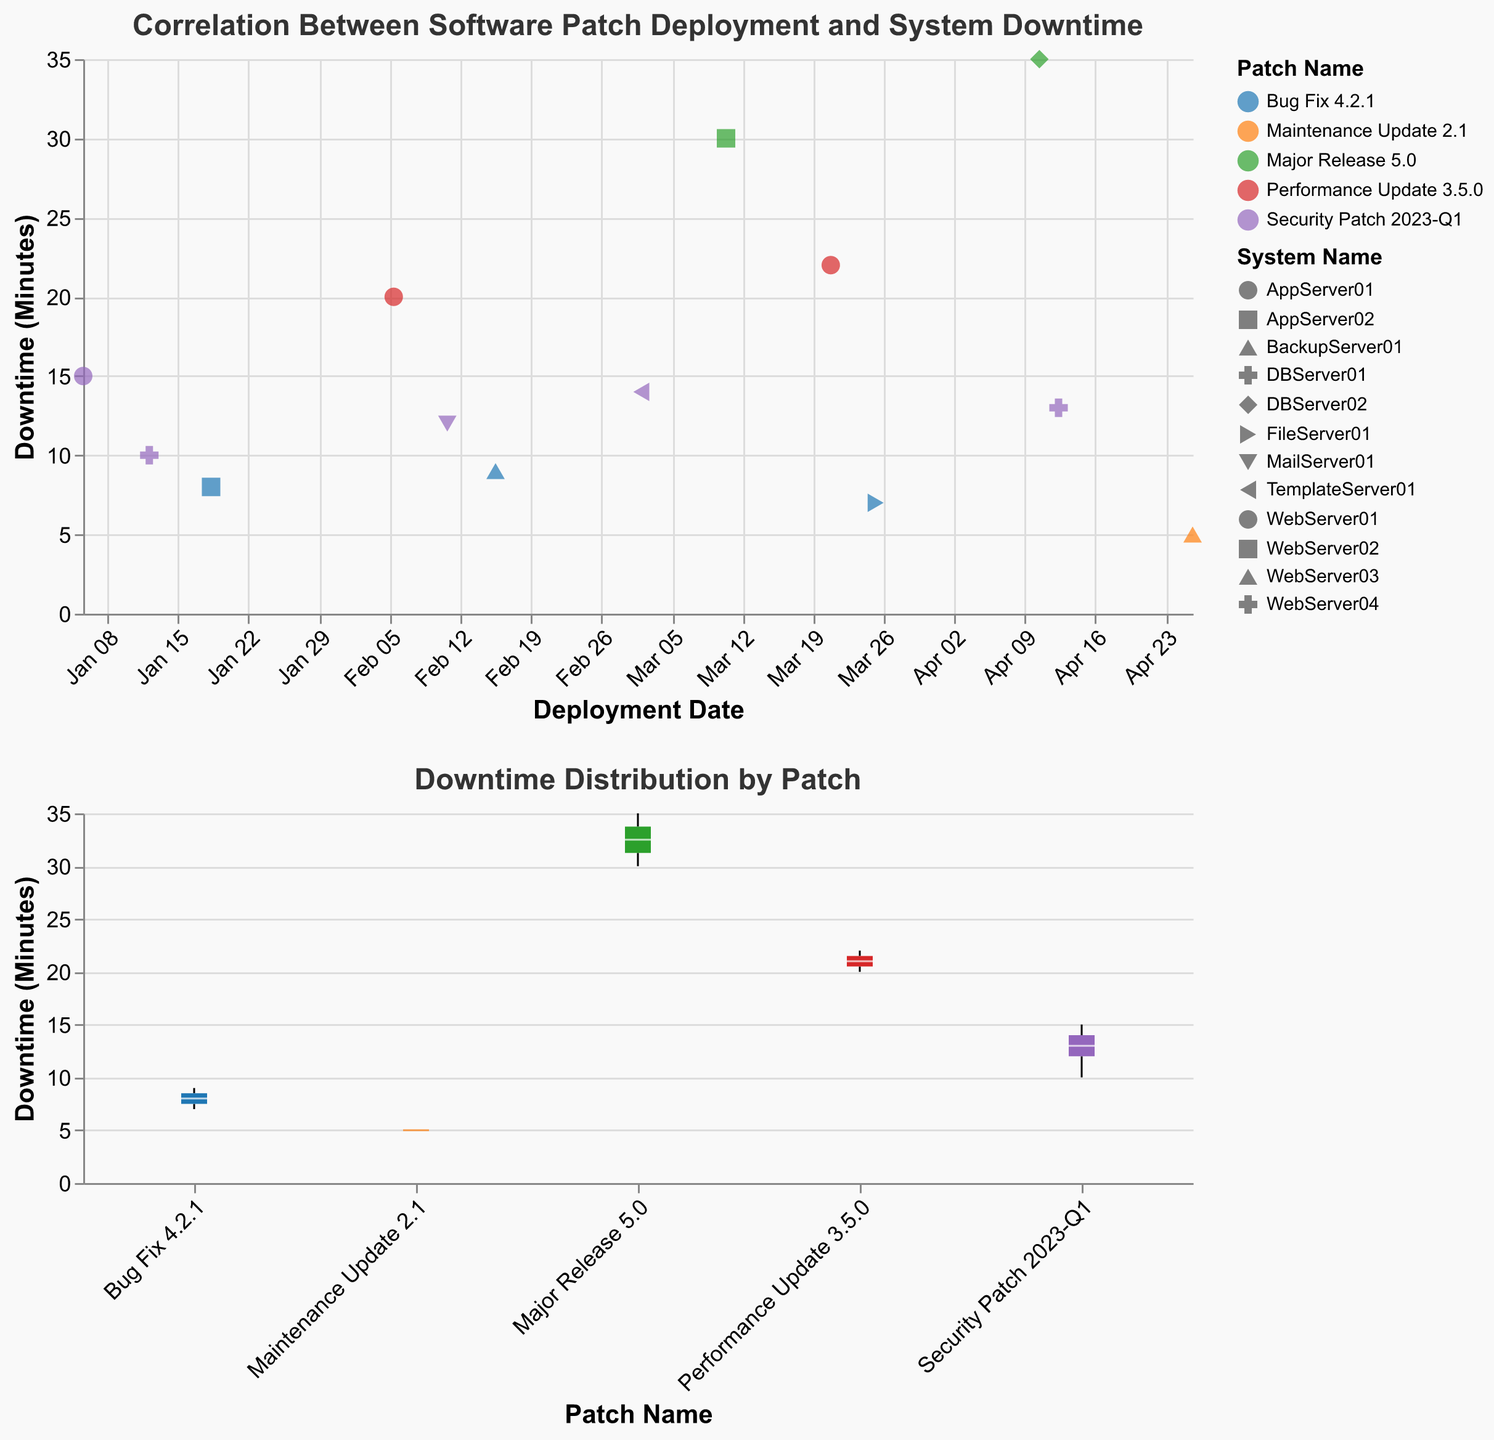What is the title of the scatter plot? The title is usually found at the top of the scatter plot. For this figure, it is specified in the "title" attribute of the Vega-Lite schema.
Answer: Correlation Between Software Patch Deployment and System Downtime What is the axis title for the x-axis? The x-axis title can be found by looking at the "x" field in the encoding section of the plot. It is labeled "Deployment Date".
Answer: Deployment Date Which patch resulted in the highest downtime? The point with the highest value on the y-axis (Downtime Minutes) is associated with the "Major Release 5.0" patch. This is verified by checking the tooltip or color coding in the scatter plot.
Answer: Major Release 5.0 How many different patch names are there? The legend for the color encoding lists all the unique patch names. Count the distinct entries listed under "Patch Name".
Answer: 5 Which system had downtime recorded on January 12, 2023? By finding the point corresponding to January 12, 2023, in the scatter plot, and reviewing the tooltip, we see that "DBServer01" had downtime recorded.
Answer: DBServer01 What's the average downtime for deployments associated with the "Bug Fix 4.2.1" patch? Identify all points colored for "Bug Fix 4.2.1" and extract their downtime values (8, 9, 7). Calculate the average: (8 + 9 + 7) / 3 = 8.
Answer: 8 Which patch had the most varied downtime results? Look at the boxplot in the second subplot, which shows the distribution of downtime for each patch. The patch with the longest range or largest box is "Major Release 5.0".
Answer: Major Release 5.0 Is there a clear trend indicating that newer deployments result in higher downtime? Examine the scatter plot for a trend from left (earlier dates) to right (later dates) on the x-axis. Assess if the points on the right consistently have higher y-axis values (Downtime Minutes).
Answer: No clear trend Which system experienced the least amount of total downtime? Calculate the total downtime for each system by summing the values associated with each system. From the data, "BackupServer01" has a single downtime of 5 minutes, the least among all systems.
Answer: BackupServer01 